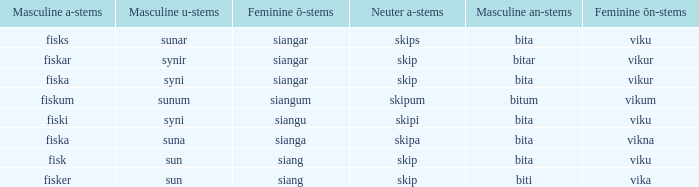What is the an-stem for the word which has an ö-stems of siangar and an u-stem ending of syni? Bita. 